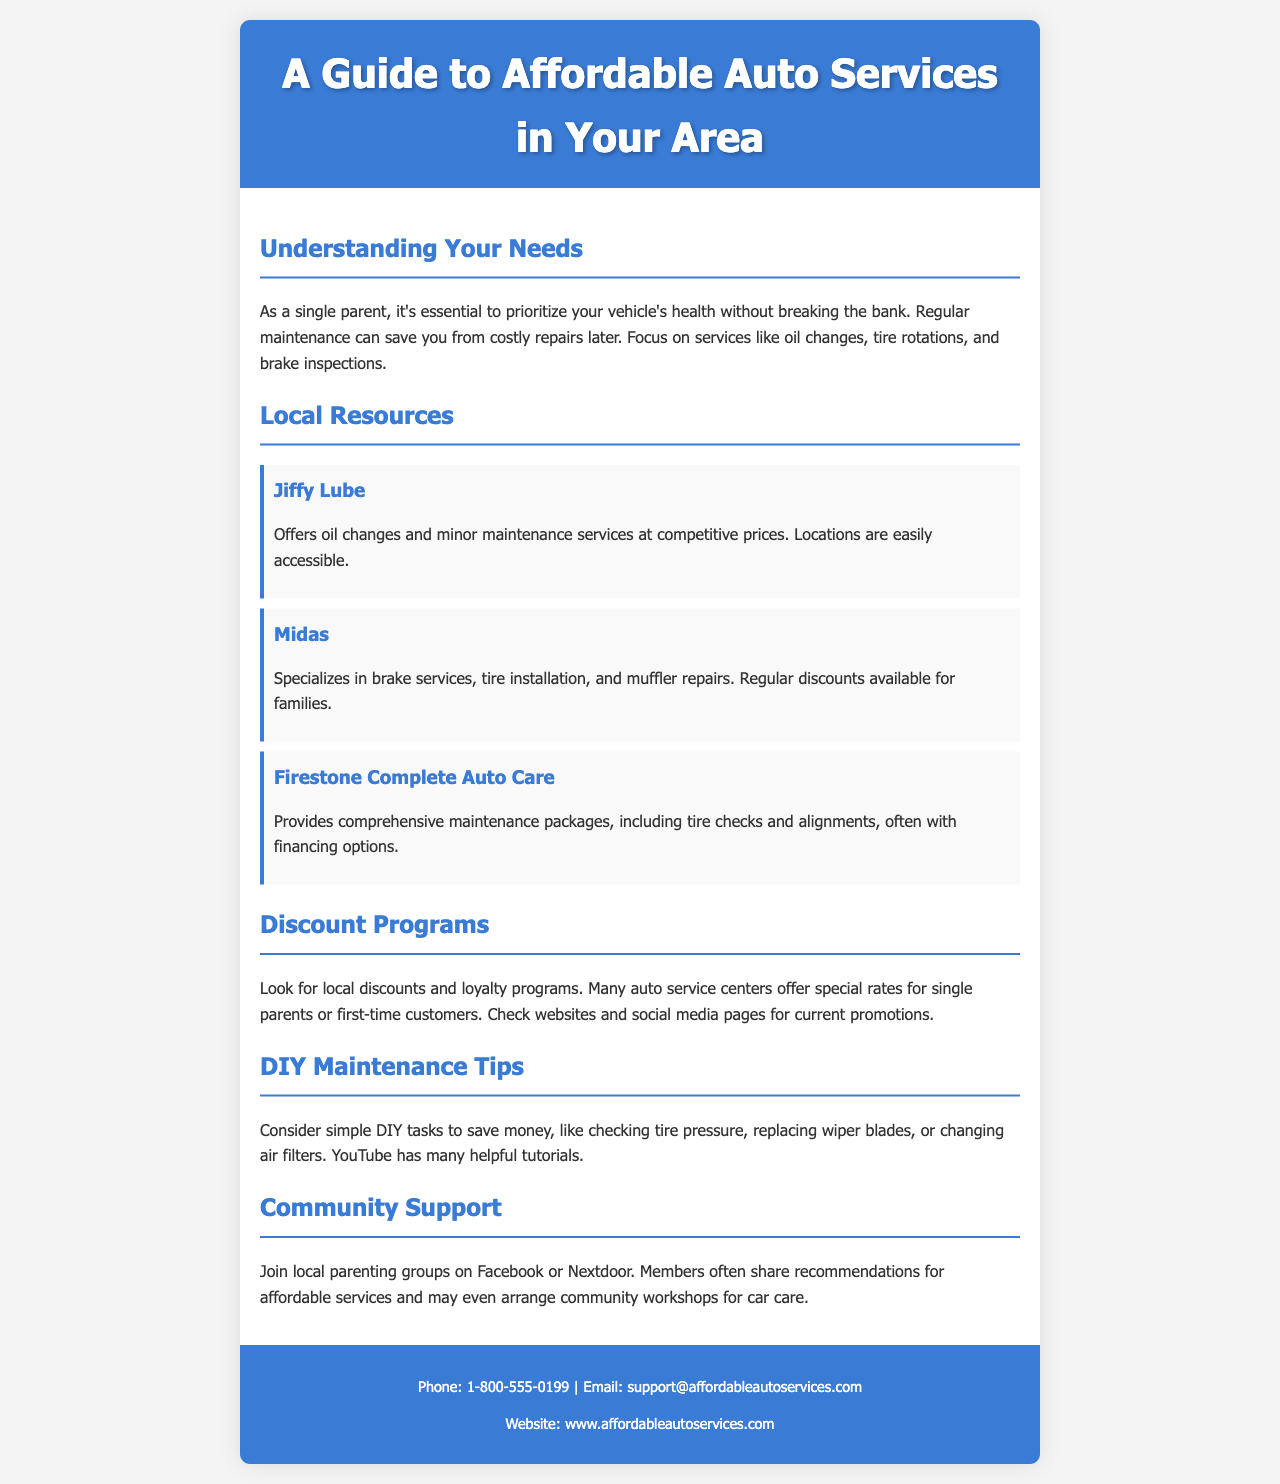What is the title of the brochure? The title of the brochure is prominently displayed in the header section.
Answer: A Guide to Affordable Auto Services in Your Area Which service offers oil changes? The brochure lists Jiffy Lube, which is dedicated to oil changes and minor maintenance services.
Answer: Jiffy Lube What type of maintenance service does Midas specialize in? Midas is mentioned to specialize in brake services, among other repairs.
Answer: Brake services How can single parents find local discounts? The brochure suggests checking websites and social media for current promotions specific to single parents.
Answer: Websites and social media What is a recommended DIY task mentioned in the brochure? The brochure suggests various DIY tasks, specifically checking tire pressure.
Answer: Checking tire pressure Which company provides comprehensive maintenance packages? The brochure includes Firestone Complete Auto Care, noted for its maintenance packages.
Answer: Firestone Complete Auto Care How can community support be accessed according to the brochure? The document advises joining local parenting groups for shared recommendations and workshops.
Answer: Local parenting groups What is the phone number provided for contact? The brochure contains a contact section that lists a specific phone number.
Answer: 1-800-555-0199 What should you focus on for your vehicle's health? The first section emphasizes the importance of regular maintenance services.
Answer: Regular maintenance 